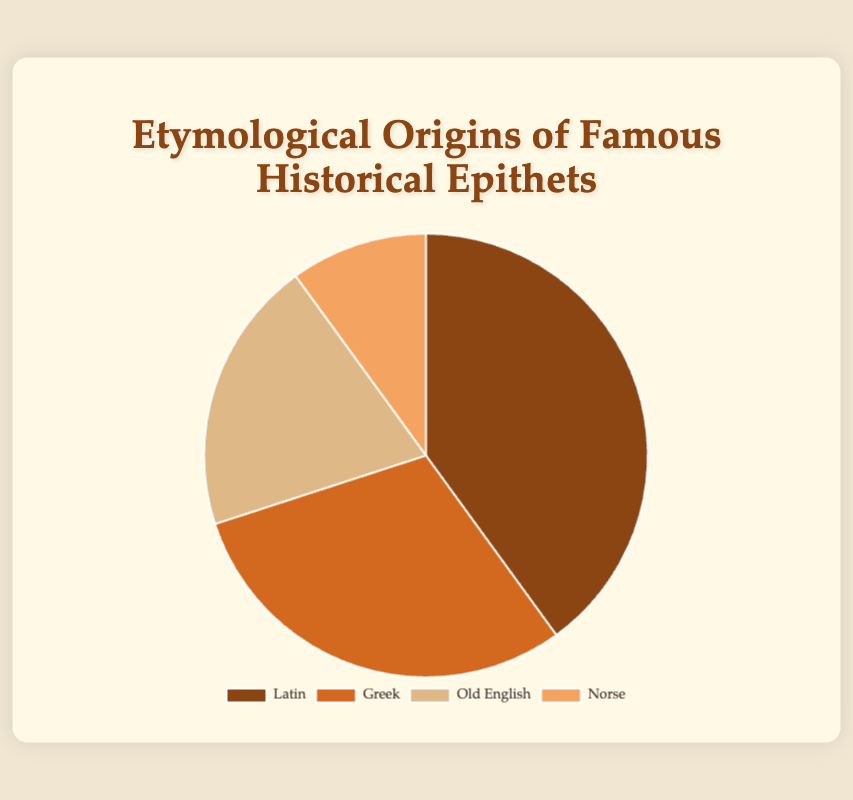Which origin has the highest percentage of epithets? The largest segment of the pie chart represents the category with the highest percentage. In this case, "Latin" occupies the largest segment.
Answer: Latin How many percentage points more does Latin have compared to Norse? Latin has 40% and Norse has 10%. The difference is 40% - 10% = 30%.
Answer: 30% What is the sum of the percentages for Greek and Old English? Greek has 30% and Old English has 20%. Adding these together gives 30% + 20% = 50%.
Answer: 50% Which origin has a larger percentage, Greek or Old English? By comparing the two segments, Greek has 30%, while Old English has 20%. Greek is larger.
Answer: Greek What percentage of epithets are derived from either Latin or Norse? Latin has 40% and Norse has 10%. Adding these percentages together gives 40% + 10% = 50%.
Answer: 50% Identify the origin with the smallest percentage of epithets. The smallest segment of the pie chart represents the origin with the smallest percentage. In this case, Norse has the smallest segment.
Answer: Norse How does the percentage for Greek epithets compare to that for Latin epithets? Greek has 30%, and Latin has 40%. Greek is 10 percentage points less than Latin.
Answer: 10% less What is the difference in percentage between the origins with the highest and lowest percentages? The highest percentage is Latin with 40%, and the lowest is Norse with 10%. The difference is 40% - 10% = 30%.
Answer: 30% If you combine the percentages of Greek and Norse, is it more than that of Latin? Greek has 30% and Norse has 10%, which sums to 40%. This is equal to the percentage of Latin, which is also 40%.
Answer: No, it's equal Which origin accounts for one-fifth of the total epithets? One-fifth of 100% is 20%. Old English represents 20% of the total in the pie chart.
Answer: Old English 